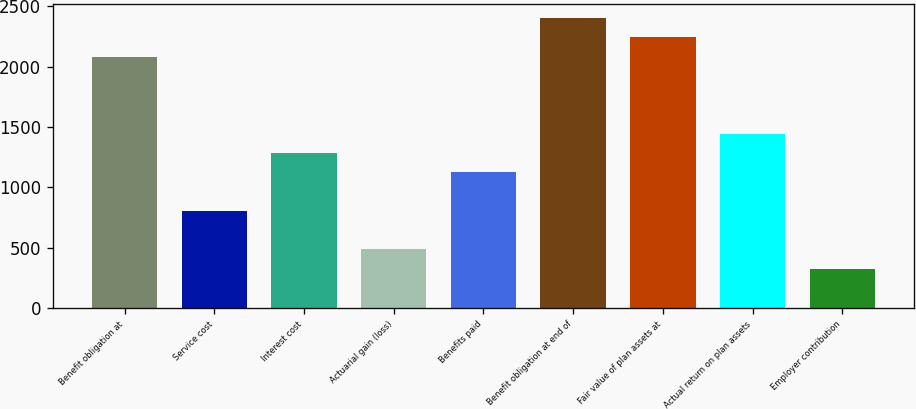<chart> <loc_0><loc_0><loc_500><loc_500><bar_chart><fcel>Benefit obligation at<fcel>Service cost<fcel>Interest cost<fcel>Actuarial gain (loss)<fcel>Benefits paid<fcel>Benefit obligation at end of<fcel>Fair value of plan assets at<fcel>Actual return on plan assets<fcel>Employer contribution<nl><fcel>2083.08<fcel>805<fcel>1284.28<fcel>485.48<fcel>1124.52<fcel>2402.6<fcel>2242.84<fcel>1444.04<fcel>325.72<nl></chart> 